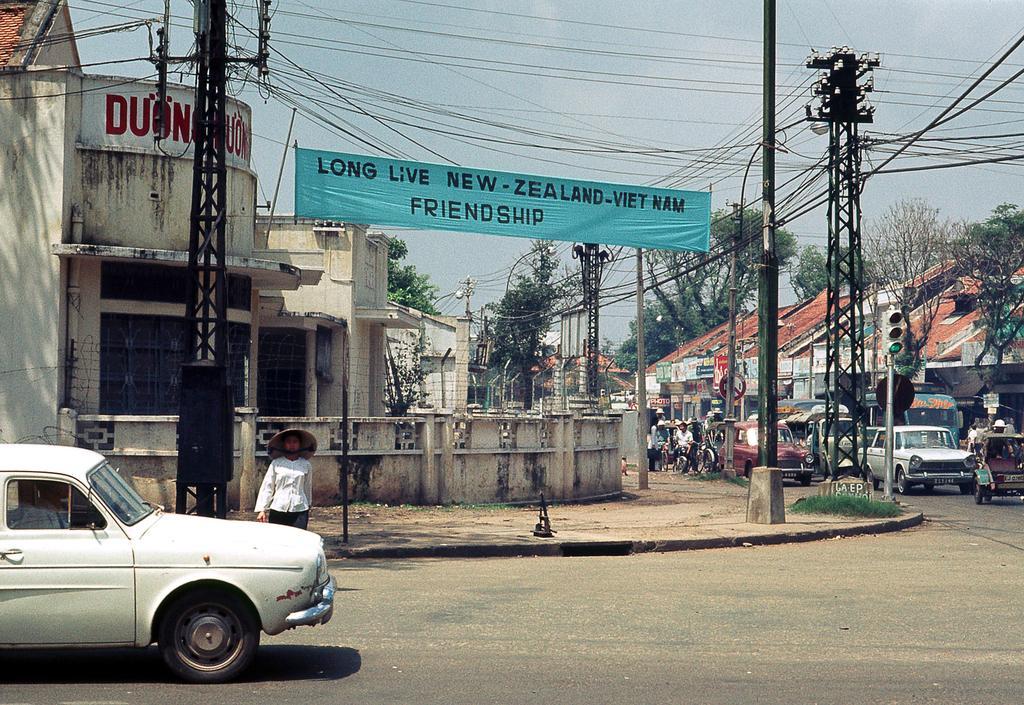Describe this image in one or two sentences. In this image I can see on the left side there is a car in white and there are buildings in the middle. On the right side there is a traffic signal and few vehicles are there on the road, at the top it is the sky. 